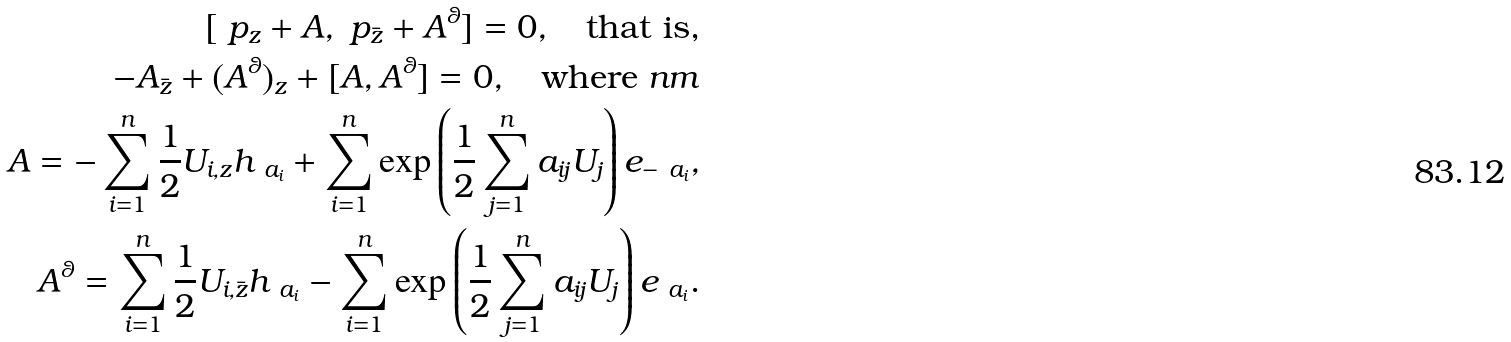Convert formula to latex. <formula><loc_0><loc_0><loc_500><loc_500>[ \ p _ { z } + A , \ p _ { \bar { z } } + A ^ { \theta } ] = 0 , \quad \text {that is,} \\ - A _ { \bar { z } } + ( A ^ { \theta } ) _ { z } + [ A , A ^ { \theta } ] = 0 , \quad \text {where} \ n m \\ A = - \sum _ { i = 1 } ^ { n } \frac { 1 } { 2 } U _ { i , z } h _ { \ a _ { i } } + \sum _ { i = 1 } ^ { n } \exp \left ( { \frac { 1 } { 2 } \sum _ { j = 1 } ^ { n } a _ { i j } U _ { j } } \right ) e _ { - \ a _ { i } } , \\ A ^ { \theta } = \sum _ { i = 1 } ^ { n } \frac { 1 } { 2 } U _ { i , \bar { z } } h _ { \ a _ { i } } - \sum _ { i = 1 } ^ { n } \exp \left ( { \frac { 1 } { 2 } \sum _ { j = 1 } ^ { n } a _ { i j } U _ { j } } \right ) e _ { \ a _ { i } } .</formula> 